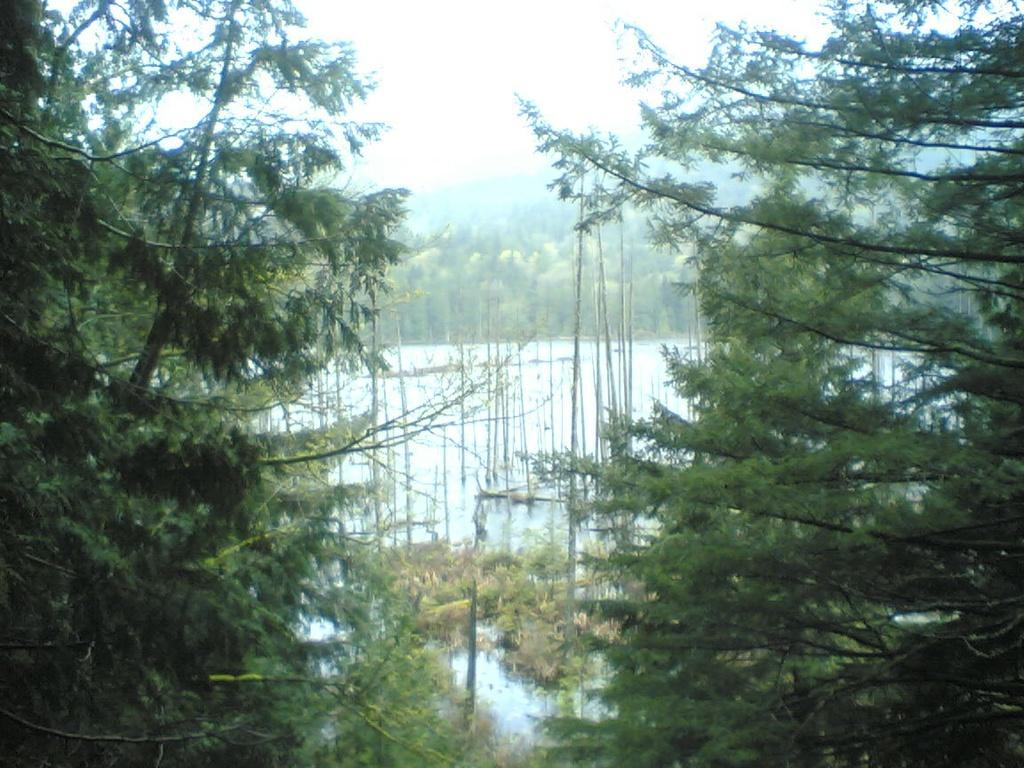What type of vegetation can be seen in the image? There are trees in the image. What structures are present in the image? There are poles in the image. What natural element is visible in the image? There is water visible in the image. What can be seen in the background of the image? There are trees and the sky visible in the background of the image. Where is the can located in the image? There is no can present in the image. What type of tooth is visible in the image? There are no teeth visible in the image. 